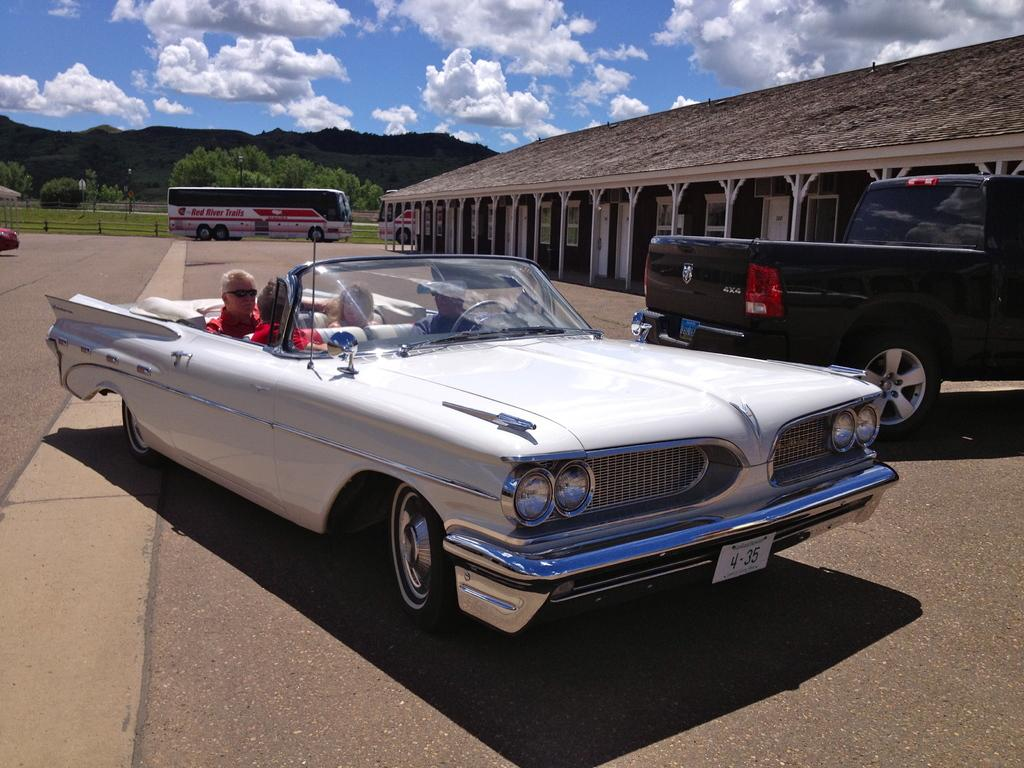What are the persons in the image doing? The persons in the image are sitting in a vehicle. Where is the vehicle located? The vehicle is on the road. What can be seen in the background of the image? There are vehicles, an open shed, trees, objects, and clouds in the sky in the background of the image. How much income do the women in the image have? There are no women mentioned in the image, so it is not possible to determine their income. 